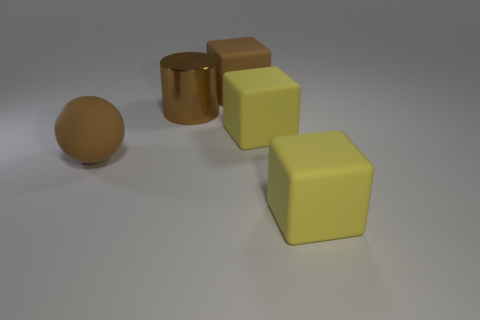Add 3 brown cubes. How many objects exist? 8 Subtract all blocks. How many objects are left? 2 Add 1 big brown metal things. How many big brown metal things exist? 2 Subtract 1 brown cylinders. How many objects are left? 4 Subtract all tiny red rubber objects. Subtract all big brown rubber blocks. How many objects are left? 4 Add 3 yellow matte blocks. How many yellow matte blocks are left? 5 